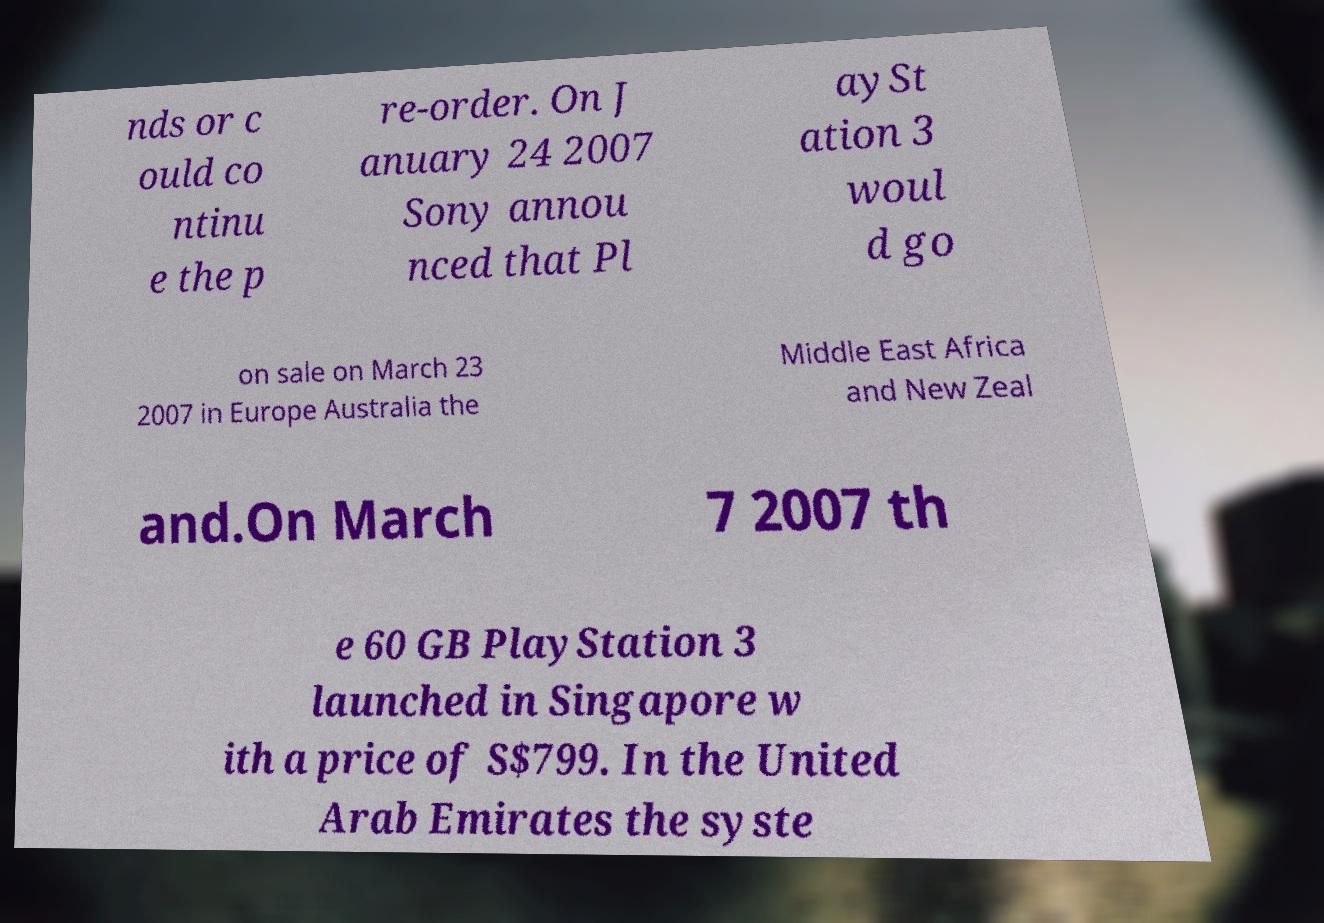Can you read and provide the text displayed in the image?This photo seems to have some interesting text. Can you extract and type it out for me? nds or c ould co ntinu e the p re-order. On J anuary 24 2007 Sony annou nced that Pl aySt ation 3 woul d go on sale on March 23 2007 in Europe Australia the Middle East Africa and New Zeal and.On March 7 2007 th e 60 GB PlayStation 3 launched in Singapore w ith a price of S$799. In the United Arab Emirates the syste 